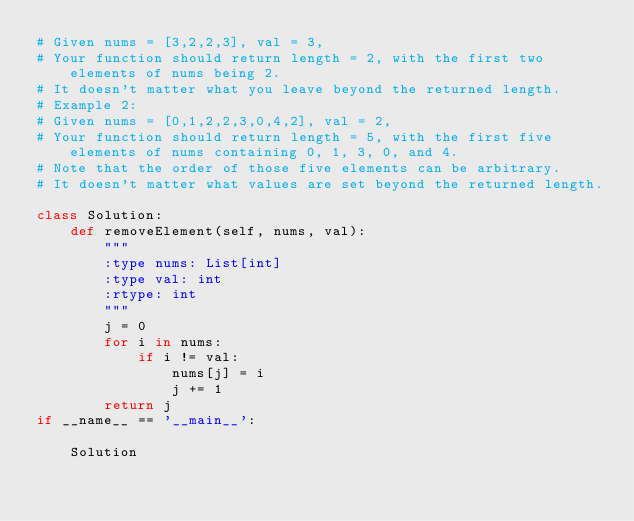<code> <loc_0><loc_0><loc_500><loc_500><_Python_># Given nums = [3,2,2,3], val = 3,
# Your function should return length = 2, with the first two elements of nums being 2.
# It doesn't matter what you leave beyond the returned length.
# Example 2:
# Given nums = [0,1,2,2,3,0,4,2], val = 2,
# Your function should return length = 5, with the first five elements of nums containing 0, 1, 3, 0, and 4.
# Note that the order of those five elements can be arbitrary.
# It doesn't matter what values are set beyond the returned length.

class Solution:
    def removeElement(self, nums, val):
        """
        :type nums: List[int]
        :type val: int
        :rtype: int
        """
        j = 0
        for i in nums:
            if i != val:
                nums[j] = i
                j += 1
        return j
if __name__ == '__main__':
    
    Solution
    </code> 